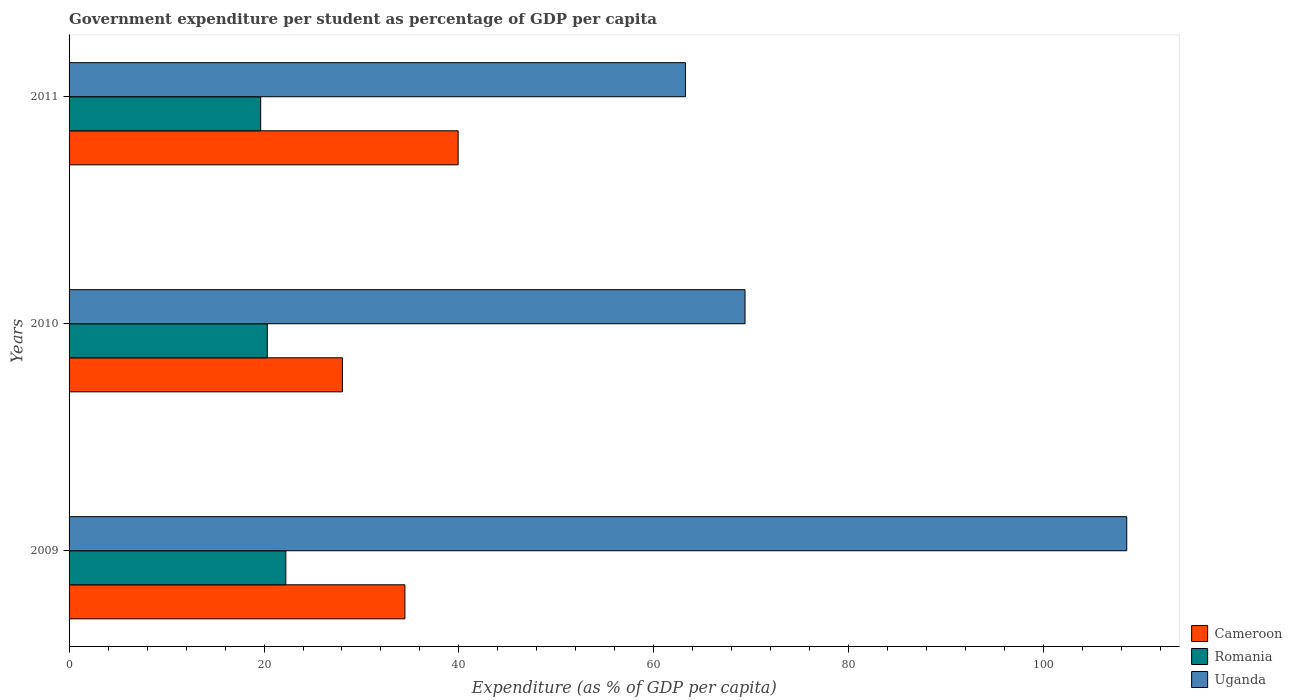Are the number of bars per tick equal to the number of legend labels?
Offer a terse response. Yes. In how many cases, is the number of bars for a given year not equal to the number of legend labels?
Give a very brief answer. 0. What is the percentage of expenditure per student in Cameroon in 2009?
Give a very brief answer. 34.46. Across all years, what is the maximum percentage of expenditure per student in Romania?
Make the answer very short. 22.24. Across all years, what is the minimum percentage of expenditure per student in Cameroon?
Keep it short and to the point. 28.04. In which year was the percentage of expenditure per student in Cameroon maximum?
Keep it short and to the point. 2011. In which year was the percentage of expenditure per student in Uganda minimum?
Provide a short and direct response. 2011. What is the total percentage of expenditure per student in Romania in the graph?
Offer a very short reply. 62.24. What is the difference between the percentage of expenditure per student in Cameroon in 2009 and that in 2010?
Offer a terse response. 6.41. What is the difference between the percentage of expenditure per student in Romania in 2010 and the percentage of expenditure per student in Cameroon in 2011?
Your answer should be very brief. -19.58. What is the average percentage of expenditure per student in Romania per year?
Your answer should be compact. 20.75. In the year 2009, what is the difference between the percentage of expenditure per student in Uganda and percentage of expenditure per student in Romania?
Ensure brevity in your answer.  86.27. What is the ratio of the percentage of expenditure per student in Romania in 2010 to that in 2011?
Make the answer very short. 1.03. Is the percentage of expenditure per student in Romania in 2009 less than that in 2010?
Offer a very short reply. No. Is the difference between the percentage of expenditure per student in Uganda in 2009 and 2011 greater than the difference between the percentage of expenditure per student in Romania in 2009 and 2011?
Offer a very short reply. Yes. What is the difference between the highest and the second highest percentage of expenditure per student in Romania?
Your answer should be compact. 1.9. What is the difference between the highest and the lowest percentage of expenditure per student in Uganda?
Keep it short and to the point. 45.27. Is the sum of the percentage of expenditure per student in Romania in 2009 and 2011 greater than the maximum percentage of expenditure per student in Uganda across all years?
Provide a succinct answer. No. What does the 2nd bar from the top in 2009 represents?
Provide a succinct answer. Romania. What does the 3rd bar from the bottom in 2009 represents?
Offer a terse response. Uganda. Is it the case that in every year, the sum of the percentage of expenditure per student in Cameroon and percentage of expenditure per student in Romania is greater than the percentage of expenditure per student in Uganda?
Ensure brevity in your answer.  No. How many bars are there?
Ensure brevity in your answer.  9. Are all the bars in the graph horizontal?
Your answer should be very brief. Yes. How many years are there in the graph?
Provide a succinct answer. 3. How are the legend labels stacked?
Your answer should be very brief. Vertical. What is the title of the graph?
Make the answer very short. Government expenditure per student as percentage of GDP per capita. What is the label or title of the X-axis?
Provide a short and direct response. Expenditure (as % of GDP per capita). What is the label or title of the Y-axis?
Your response must be concise. Years. What is the Expenditure (as % of GDP per capita) in Cameroon in 2009?
Offer a terse response. 34.46. What is the Expenditure (as % of GDP per capita) of Romania in 2009?
Your response must be concise. 22.24. What is the Expenditure (as % of GDP per capita) in Uganda in 2009?
Ensure brevity in your answer.  108.51. What is the Expenditure (as % of GDP per capita) in Cameroon in 2010?
Offer a very short reply. 28.04. What is the Expenditure (as % of GDP per capita) of Romania in 2010?
Your response must be concise. 20.34. What is the Expenditure (as % of GDP per capita) of Uganda in 2010?
Offer a terse response. 69.35. What is the Expenditure (as % of GDP per capita) of Cameroon in 2011?
Offer a very short reply. 39.92. What is the Expenditure (as % of GDP per capita) in Romania in 2011?
Provide a succinct answer. 19.66. What is the Expenditure (as % of GDP per capita) in Uganda in 2011?
Your answer should be very brief. 63.24. Across all years, what is the maximum Expenditure (as % of GDP per capita) of Cameroon?
Make the answer very short. 39.92. Across all years, what is the maximum Expenditure (as % of GDP per capita) of Romania?
Your answer should be compact. 22.24. Across all years, what is the maximum Expenditure (as % of GDP per capita) in Uganda?
Provide a short and direct response. 108.51. Across all years, what is the minimum Expenditure (as % of GDP per capita) in Cameroon?
Keep it short and to the point. 28.04. Across all years, what is the minimum Expenditure (as % of GDP per capita) of Romania?
Your answer should be compact. 19.66. Across all years, what is the minimum Expenditure (as % of GDP per capita) in Uganda?
Give a very brief answer. 63.24. What is the total Expenditure (as % of GDP per capita) in Cameroon in the graph?
Offer a very short reply. 102.42. What is the total Expenditure (as % of GDP per capita) in Romania in the graph?
Keep it short and to the point. 62.24. What is the total Expenditure (as % of GDP per capita) of Uganda in the graph?
Keep it short and to the point. 241.1. What is the difference between the Expenditure (as % of GDP per capita) of Cameroon in 2009 and that in 2010?
Your response must be concise. 6.41. What is the difference between the Expenditure (as % of GDP per capita) of Romania in 2009 and that in 2010?
Provide a succinct answer. 1.9. What is the difference between the Expenditure (as % of GDP per capita) in Uganda in 2009 and that in 2010?
Provide a short and direct response. 39.16. What is the difference between the Expenditure (as % of GDP per capita) of Cameroon in 2009 and that in 2011?
Keep it short and to the point. -5.46. What is the difference between the Expenditure (as % of GDP per capita) of Romania in 2009 and that in 2011?
Your response must be concise. 2.58. What is the difference between the Expenditure (as % of GDP per capita) of Uganda in 2009 and that in 2011?
Ensure brevity in your answer.  45.27. What is the difference between the Expenditure (as % of GDP per capita) in Cameroon in 2010 and that in 2011?
Your answer should be very brief. -11.87. What is the difference between the Expenditure (as % of GDP per capita) of Romania in 2010 and that in 2011?
Give a very brief answer. 0.68. What is the difference between the Expenditure (as % of GDP per capita) in Uganda in 2010 and that in 2011?
Your response must be concise. 6.11. What is the difference between the Expenditure (as % of GDP per capita) of Cameroon in 2009 and the Expenditure (as % of GDP per capita) of Romania in 2010?
Offer a terse response. 14.12. What is the difference between the Expenditure (as % of GDP per capita) of Cameroon in 2009 and the Expenditure (as % of GDP per capita) of Uganda in 2010?
Offer a very short reply. -34.89. What is the difference between the Expenditure (as % of GDP per capita) of Romania in 2009 and the Expenditure (as % of GDP per capita) of Uganda in 2010?
Offer a terse response. -47.11. What is the difference between the Expenditure (as % of GDP per capita) in Cameroon in 2009 and the Expenditure (as % of GDP per capita) in Romania in 2011?
Your answer should be compact. 14.79. What is the difference between the Expenditure (as % of GDP per capita) in Cameroon in 2009 and the Expenditure (as % of GDP per capita) in Uganda in 2011?
Keep it short and to the point. -28.78. What is the difference between the Expenditure (as % of GDP per capita) in Romania in 2009 and the Expenditure (as % of GDP per capita) in Uganda in 2011?
Offer a very short reply. -41. What is the difference between the Expenditure (as % of GDP per capita) in Cameroon in 2010 and the Expenditure (as % of GDP per capita) in Romania in 2011?
Offer a terse response. 8.38. What is the difference between the Expenditure (as % of GDP per capita) in Cameroon in 2010 and the Expenditure (as % of GDP per capita) in Uganda in 2011?
Provide a succinct answer. -35.19. What is the difference between the Expenditure (as % of GDP per capita) in Romania in 2010 and the Expenditure (as % of GDP per capita) in Uganda in 2011?
Provide a short and direct response. -42.9. What is the average Expenditure (as % of GDP per capita) in Cameroon per year?
Provide a short and direct response. 34.14. What is the average Expenditure (as % of GDP per capita) in Romania per year?
Ensure brevity in your answer.  20.75. What is the average Expenditure (as % of GDP per capita) in Uganda per year?
Your answer should be compact. 80.37. In the year 2009, what is the difference between the Expenditure (as % of GDP per capita) in Cameroon and Expenditure (as % of GDP per capita) in Romania?
Offer a terse response. 12.22. In the year 2009, what is the difference between the Expenditure (as % of GDP per capita) in Cameroon and Expenditure (as % of GDP per capita) in Uganda?
Ensure brevity in your answer.  -74.06. In the year 2009, what is the difference between the Expenditure (as % of GDP per capita) of Romania and Expenditure (as % of GDP per capita) of Uganda?
Provide a short and direct response. -86.27. In the year 2010, what is the difference between the Expenditure (as % of GDP per capita) of Cameroon and Expenditure (as % of GDP per capita) of Romania?
Offer a very short reply. 7.71. In the year 2010, what is the difference between the Expenditure (as % of GDP per capita) in Cameroon and Expenditure (as % of GDP per capita) in Uganda?
Provide a succinct answer. -41.31. In the year 2010, what is the difference between the Expenditure (as % of GDP per capita) of Romania and Expenditure (as % of GDP per capita) of Uganda?
Ensure brevity in your answer.  -49.01. In the year 2011, what is the difference between the Expenditure (as % of GDP per capita) of Cameroon and Expenditure (as % of GDP per capita) of Romania?
Make the answer very short. 20.26. In the year 2011, what is the difference between the Expenditure (as % of GDP per capita) of Cameroon and Expenditure (as % of GDP per capita) of Uganda?
Give a very brief answer. -23.32. In the year 2011, what is the difference between the Expenditure (as % of GDP per capita) of Romania and Expenditure (as % of GDP per capita) of Uganda?
Make the answer very short. -43.58. What is the ratio of the Expenditure (as % of GDP per capita) in Cameroon in 2009 to that in 2010?
Provide a short and direct response. 1.23. What is the ratio of the Expenditure (as % of GDP per capita) of Romania in 2009 to that in 2010?
Provide a short and direct response. 1.09. What is the ratio of the Expenditure (as % of GDP per capita) in Uganda in 2009 to that in 2010?
Your answer should be very brief. 1.56. What is the ratio of the Expenditure (as % of GDP per capita) of Cameroon in 2009 to that in 2011?
Your answer should be very brief. 0.86. What is the ratio of the Expenditure (as % of GDP per capita) in Romania in 2009 to that in 2011?
Your response must be concise. 1.13. What is the ratio of the Expenditure (as % of GDP per capita) in Uganda in 2009 to that in 2011?
Give a very brief answer. 1.72. What is the ratio of the Expenditure (as % of GDP per capita) in Cameroon in 2010 to that in 2011?
Your answer should be very brief. 0.7. What is the ratio of the Expenditure (as % of GDP per capita) of Romania in 2010 to that in 2011?
Offer a terse response. 1.03. What is the ratio of the Expenditure (as % of GDP per capita) of Uganda in 2010 to that in 2011?
Your response must be concise. 1.1. What is the difference between the highest and the second highest Expenditure (as % of GDP per capita) in Cameroon?
Provide a short and direct response. 5.46. What is the difference between the highest and the second highest Expenditure (as % of GDP per capita) in Romania?
Offer a terse response. 1.9. What is the difference between the highest and the second highest Expenditure (as % of GDP per capita) of Uganda?
Provide a short and direct response. 39.16. What is the difference between the highest and the lowest Expenditure (as % of GDP per capita) of Cameroon?
Make the answer very short. 11.87. What is the difference between the highest and the lowest Expenditure (as % of GDP per capita) of Romania?
Keep it short and to the point. 2.58. What is the difference between the highest and the lowest Expenditure (as % of GDP per capita) of Uganda?
Offer a very short reply. 45.27. 